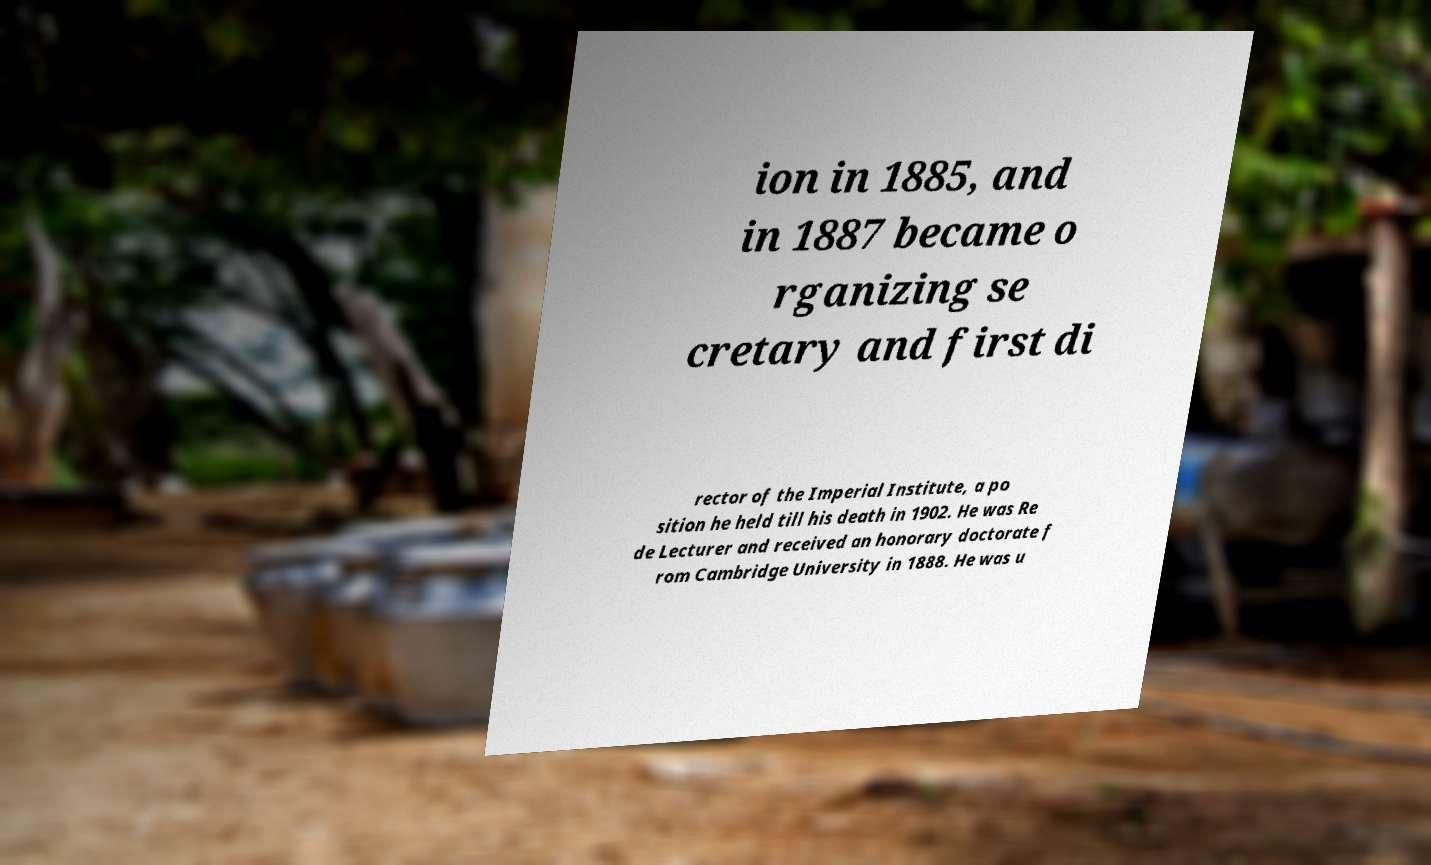I need the written content from this picture converted into text. Can you do that? ion in 1885, and in 1887 became o rganizing se cretary and first di rector of the Imperial Institute, a po sition he held till his death in 1902. He was Re de Lecturer and received an honorary doctorate f rom Cambridge University in 1888. He was u 